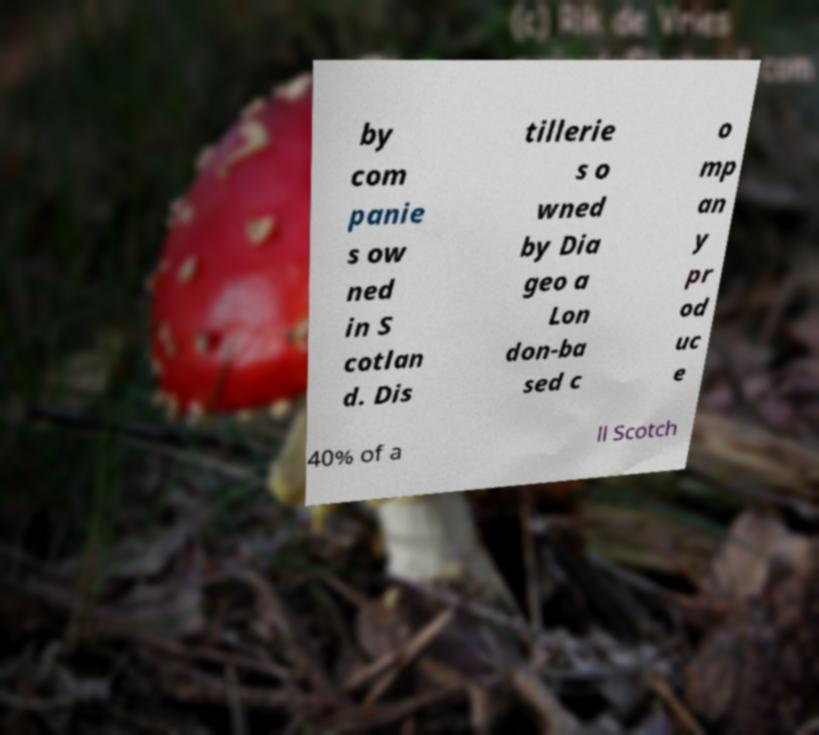For documentation purposes, I need the text within this image transcribed. Could you provide that? by com panie s ow ned in S cotlan d. Dis tillerie s o wned by Dia geo a Lon don-ba sed c o mp an y pr od uc e 40% of a ll Scotch 